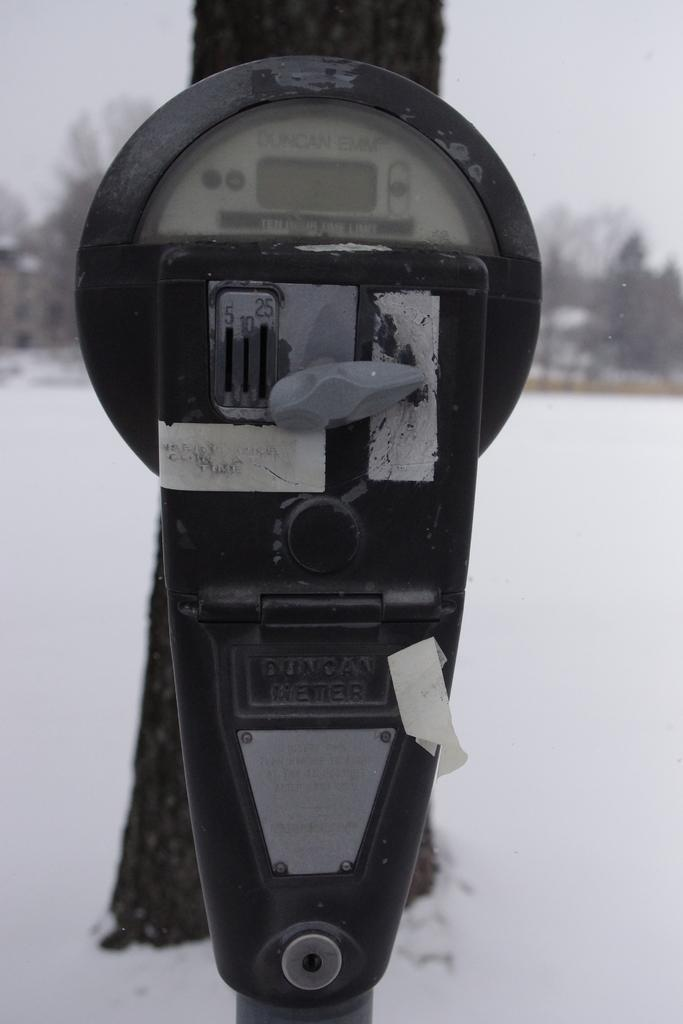<image>
Give a short and clear explanation of the subsequent image. A parking meter sits in the snow and it black and silver and says ten hour limit on it. 